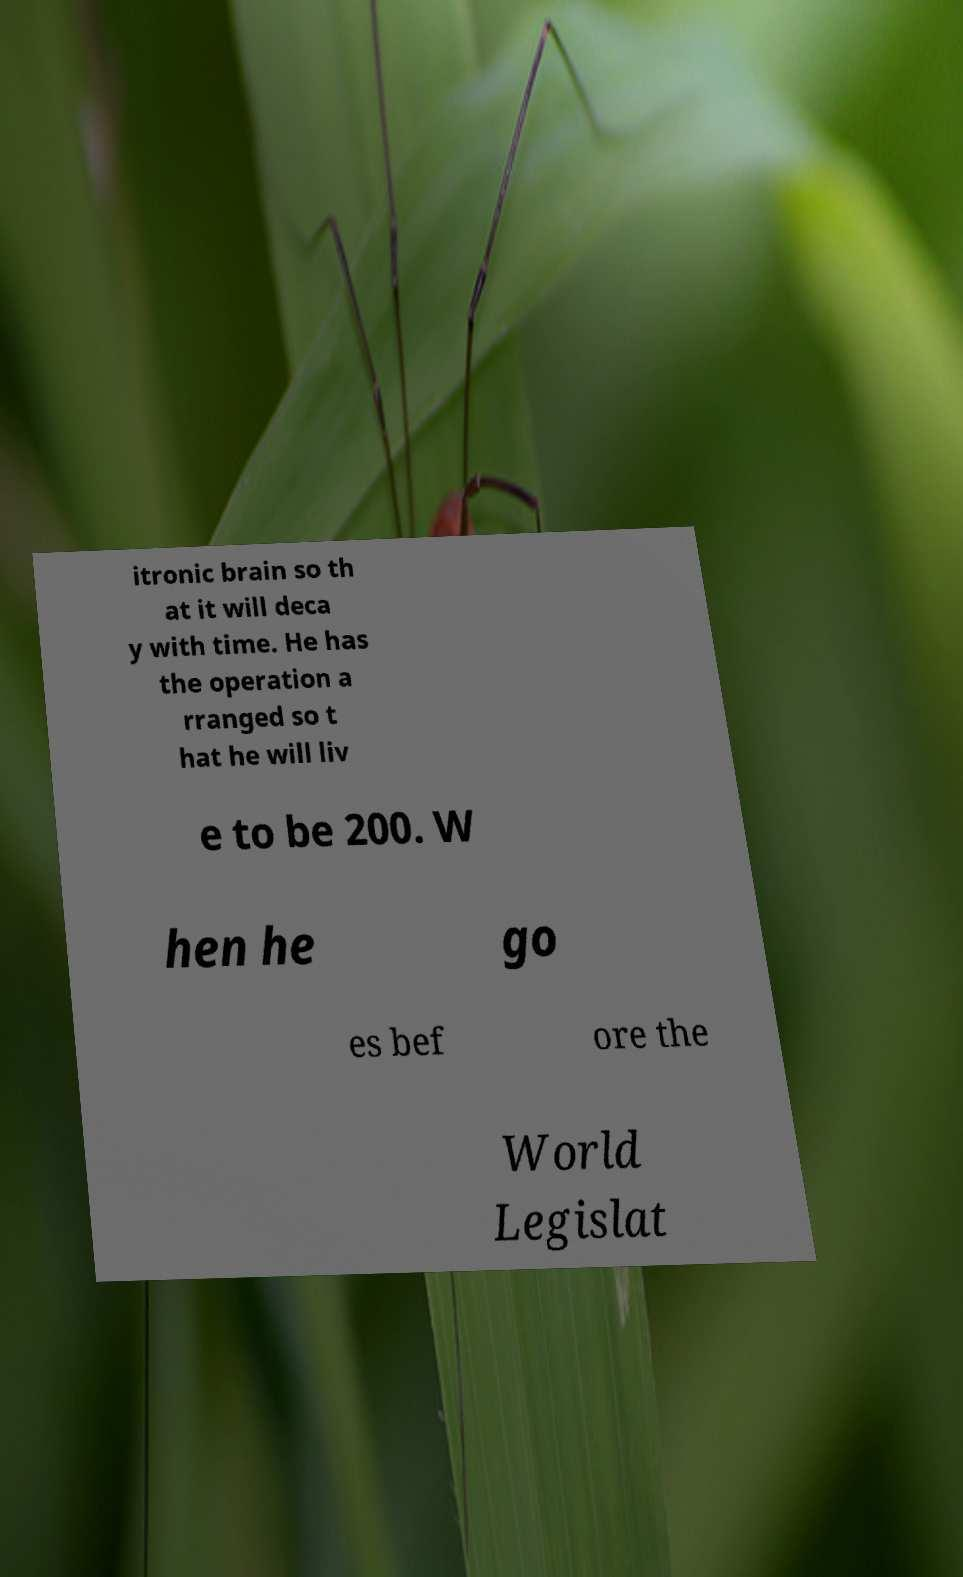Could you assist in decoding the text presented in this image and type it out clearly? itronic brain so th at it will deca y with time. He has the operation a rranged so t hat he will liv e to be 200. W hen he go es bef ore the World Legislat 